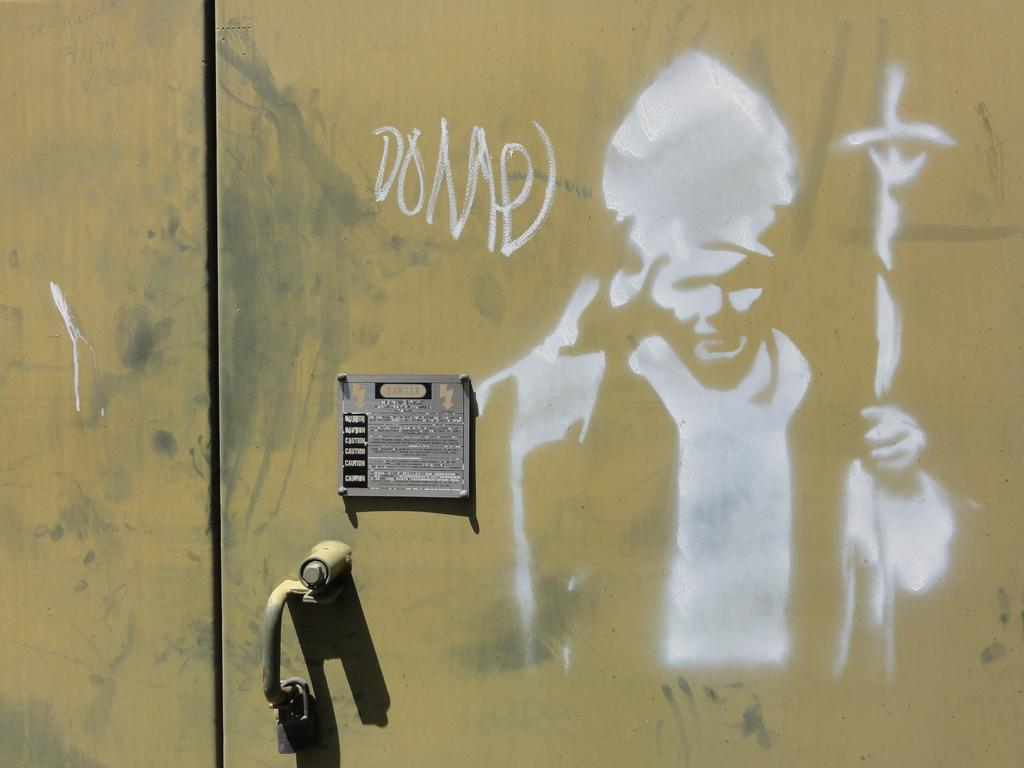What is the main object in the middle of the image? There is a door in the middle of the image. What can be observed on the door? The door has paint on it, text, and a board. How many feet are visible on the door in the image? There are no feet visible on the door in the image. 